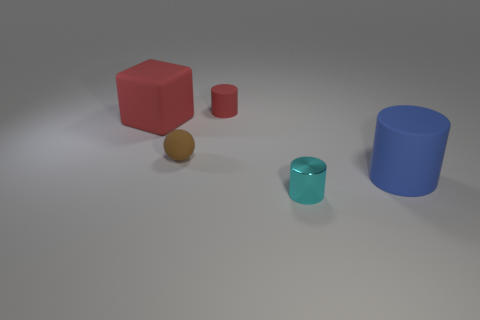What number of small objects are cyan things or purple cylinders?
Offer a terse response. 1. Does the large cube have the same material as the cyan object?
Keep it short and to the point. No. What is the size of the thing that is the same color as the tiny matte cylinder?
Keep it short and to the point. Large. Is there a thing that has the same color as the big matte block?
Offer a very short reply. Yes. There is a blue object that is made of the same material as the big red thing; what is its size?
Your answer should be very brief. Large. The tiny thing that is behind the big object that is to the left of the matte cylinder that is behind the brown rubber ball is what shape?
Keep it short and to the point. Cylinder. What is the size of the red object that is the same shape as the large blue object?
Your answer should be very brief. Small. What is the size of the thing that is to the left of the tiny matte cylinder and in front of the block?
Ensure brevity in your answer.  Small. What shape is the object that is the same color as the tiny matte cylinder?
Your answer should be compact. Cube. What is the color of the small rubber sphere?
Make the answer very short. Brown. 